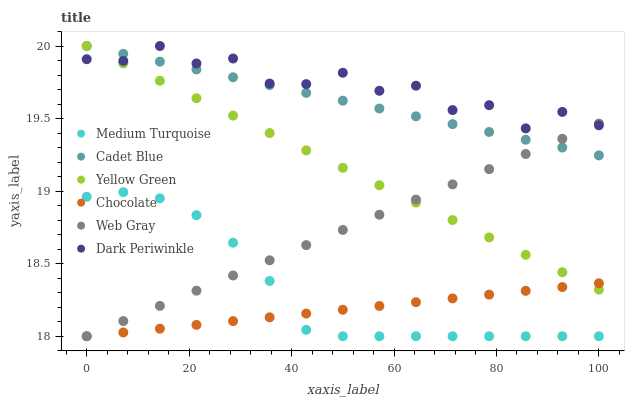Does Chocolate have the minimum area under the curve?
Answer yes or no. Yes. Does Dark Periwinkle have the maximum area under the curve?
Answer yes or no. Yes. Does Yellow Green have the minimum area under the curve?
Answer yes or no. No. Does Yellow Green have the maximum area under the curve?
Answer yes or no. No. Is Chocolate the smoothest?
Answer yes or no. Yes. Is Dark Periwinkle the roughest?
Answer yes or no. Yes. Is Yellow Green the smoothest?
Answer yes or no. No. Is Yellow Green the roughest?
Answer yes or no. No. Does Chocolate have the lowest value?
Answer yes or no. Yes. Does Yellow Green have the lowest value?
Answer yes or no. No. Does Dark Periwinkle have the highest value?
Answer yes or no. Yes. Does Chocolate have the highest value?
Answer yes or no. No. Is Chocolate less than Cadet Blue?
Answer yes or no. Yes. Is Dark Periwinkle greater than Medium Turquoise?
Answer yes or no. Yes. Does Web Gray intersect Chocolate?
Answer yes or no. Yes. Is Web Gray less than Chocolate?
Answer yes or no. No. Is Web Gray greater than Chocolate?
Answer yes or no. No. Does Chocolate intersect Cadet Blue?
Answer yes or no. No. 